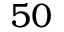<formula> <loc_0><loc_0><loc_500><loc_500>5 0</formula> 